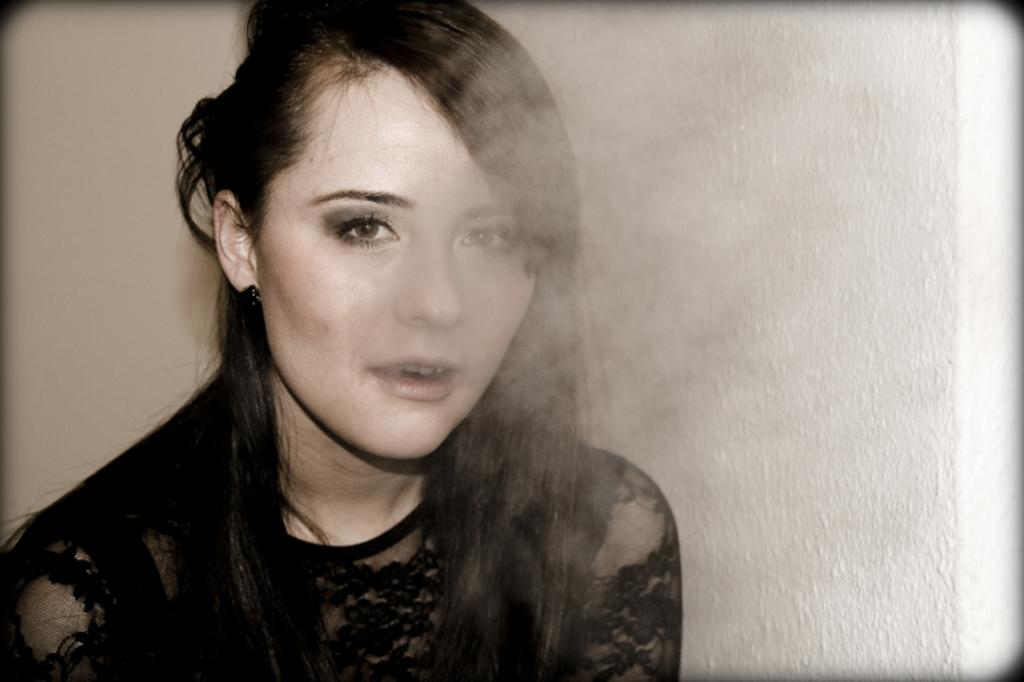Who is present in the image? There is a woman in the image. What is the woman wearing? The woman is wearing a black dress. What is the woman doing in the image? The woman is releasing smoke from her mouth. What can be seen in the background of the image? There is a white wall in the background of the image. What type of theory is the girl discussing in the image? There is no girl present in the image, and no discussion of any theory can be observed. 